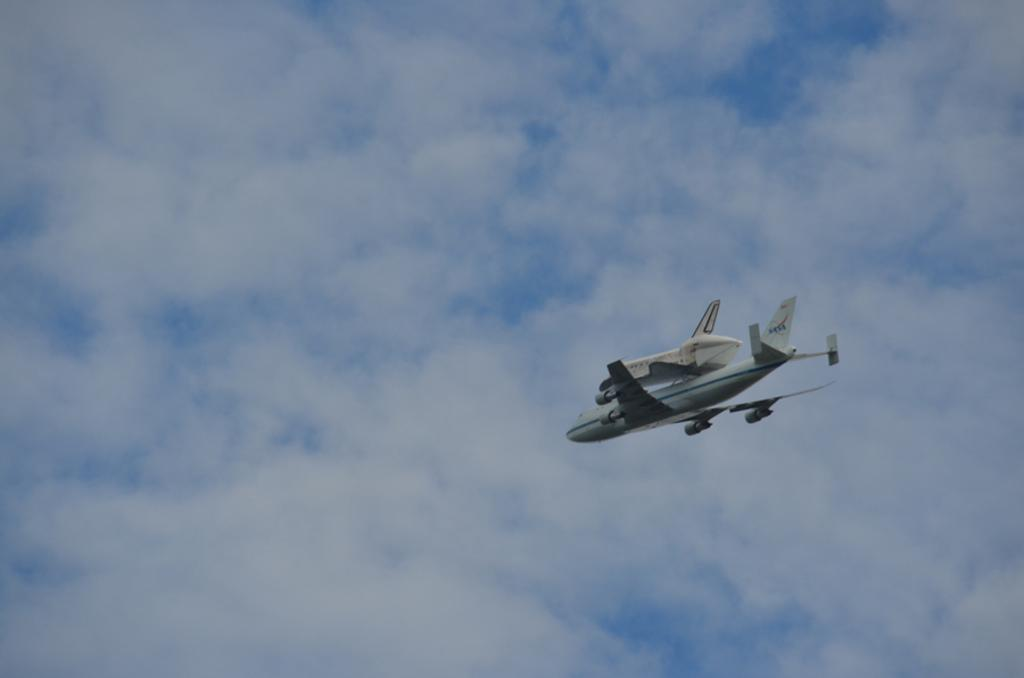Where was the image taken? The image was taken outdoors. What can be seen in the background of the image? There is a sky with clouds visible in the background. What is flying in the sky in the middle of the image? An airplane is flying in the sky in the middle of the image. How many fingers does the star have in the image? There is no star present in the image, and therefore no fingers can be counted. 